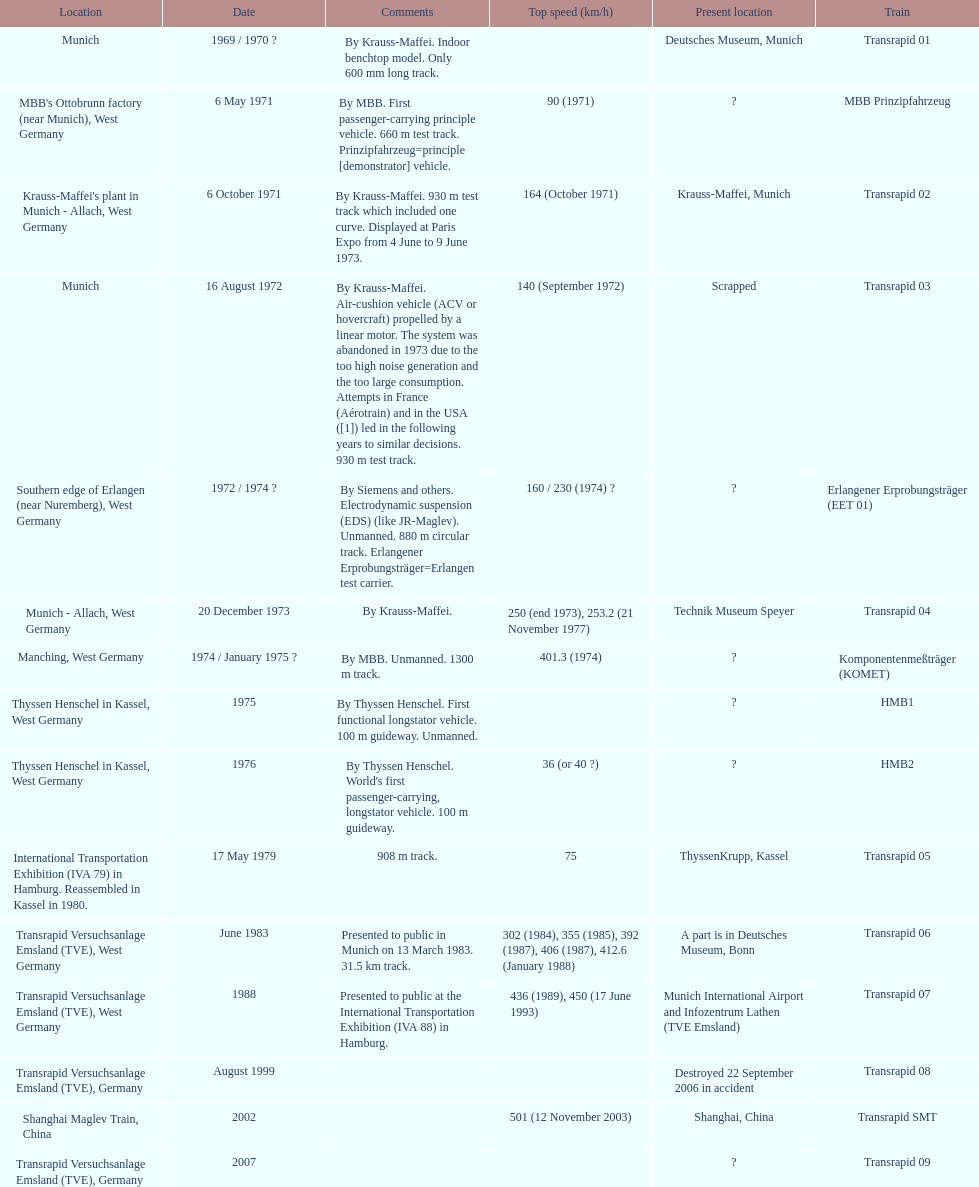How many trains listed have the same speed as the hmb2? 0. 